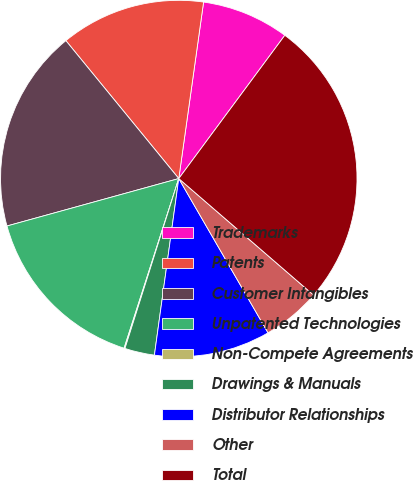<chart> <loc_0><loc_0><loc_500><loc_500><pie_chart><fcel>Trademarks<fcel>Patents<fcel>Customer Intangibles<fcel>Unpatented Technologies<fcel>Non-Compete Agreements<fcel>Drawings & Manuals<fcel>Distributor Relationships<fcel>Other<fcel>Total<nl><fcel>7.92%<fcel>13.14%<fcel>18.37%<fcel>15.75%<fcel>0.08%<fcel>2.7%<fcel>10.53%<fcel>5.31%<fcel>26.2%<nl></chart> 